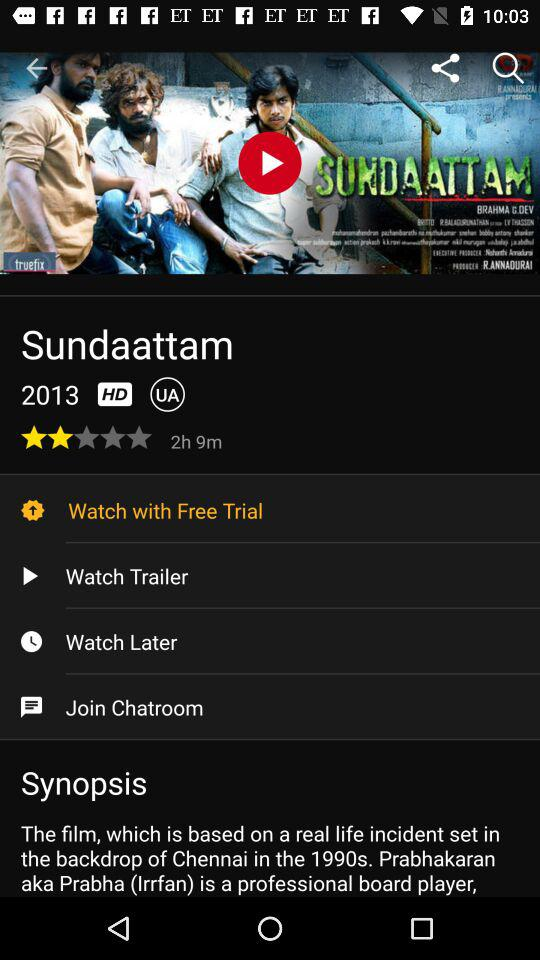How many minutes is the movie?
Answer the question using a single word or phrase. 129 